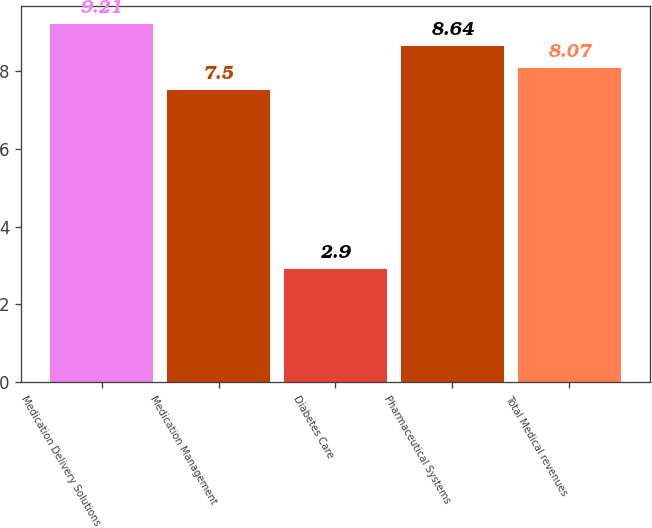Convert chart to OTSL. <chart><loc_0><loc_0><loc_500><loc_500><bar_chart><fcel>Medication Delivery Solutions<fcel>Medication Management<fcel>Diabetes Care<fcel>Pharmaceutical Systems<fcel>Total Medical revenues<nl><fcel>9.21<fcel>7.5<fcel>2.9<fcel>8.64<fcel>8.07<nl></chart> 